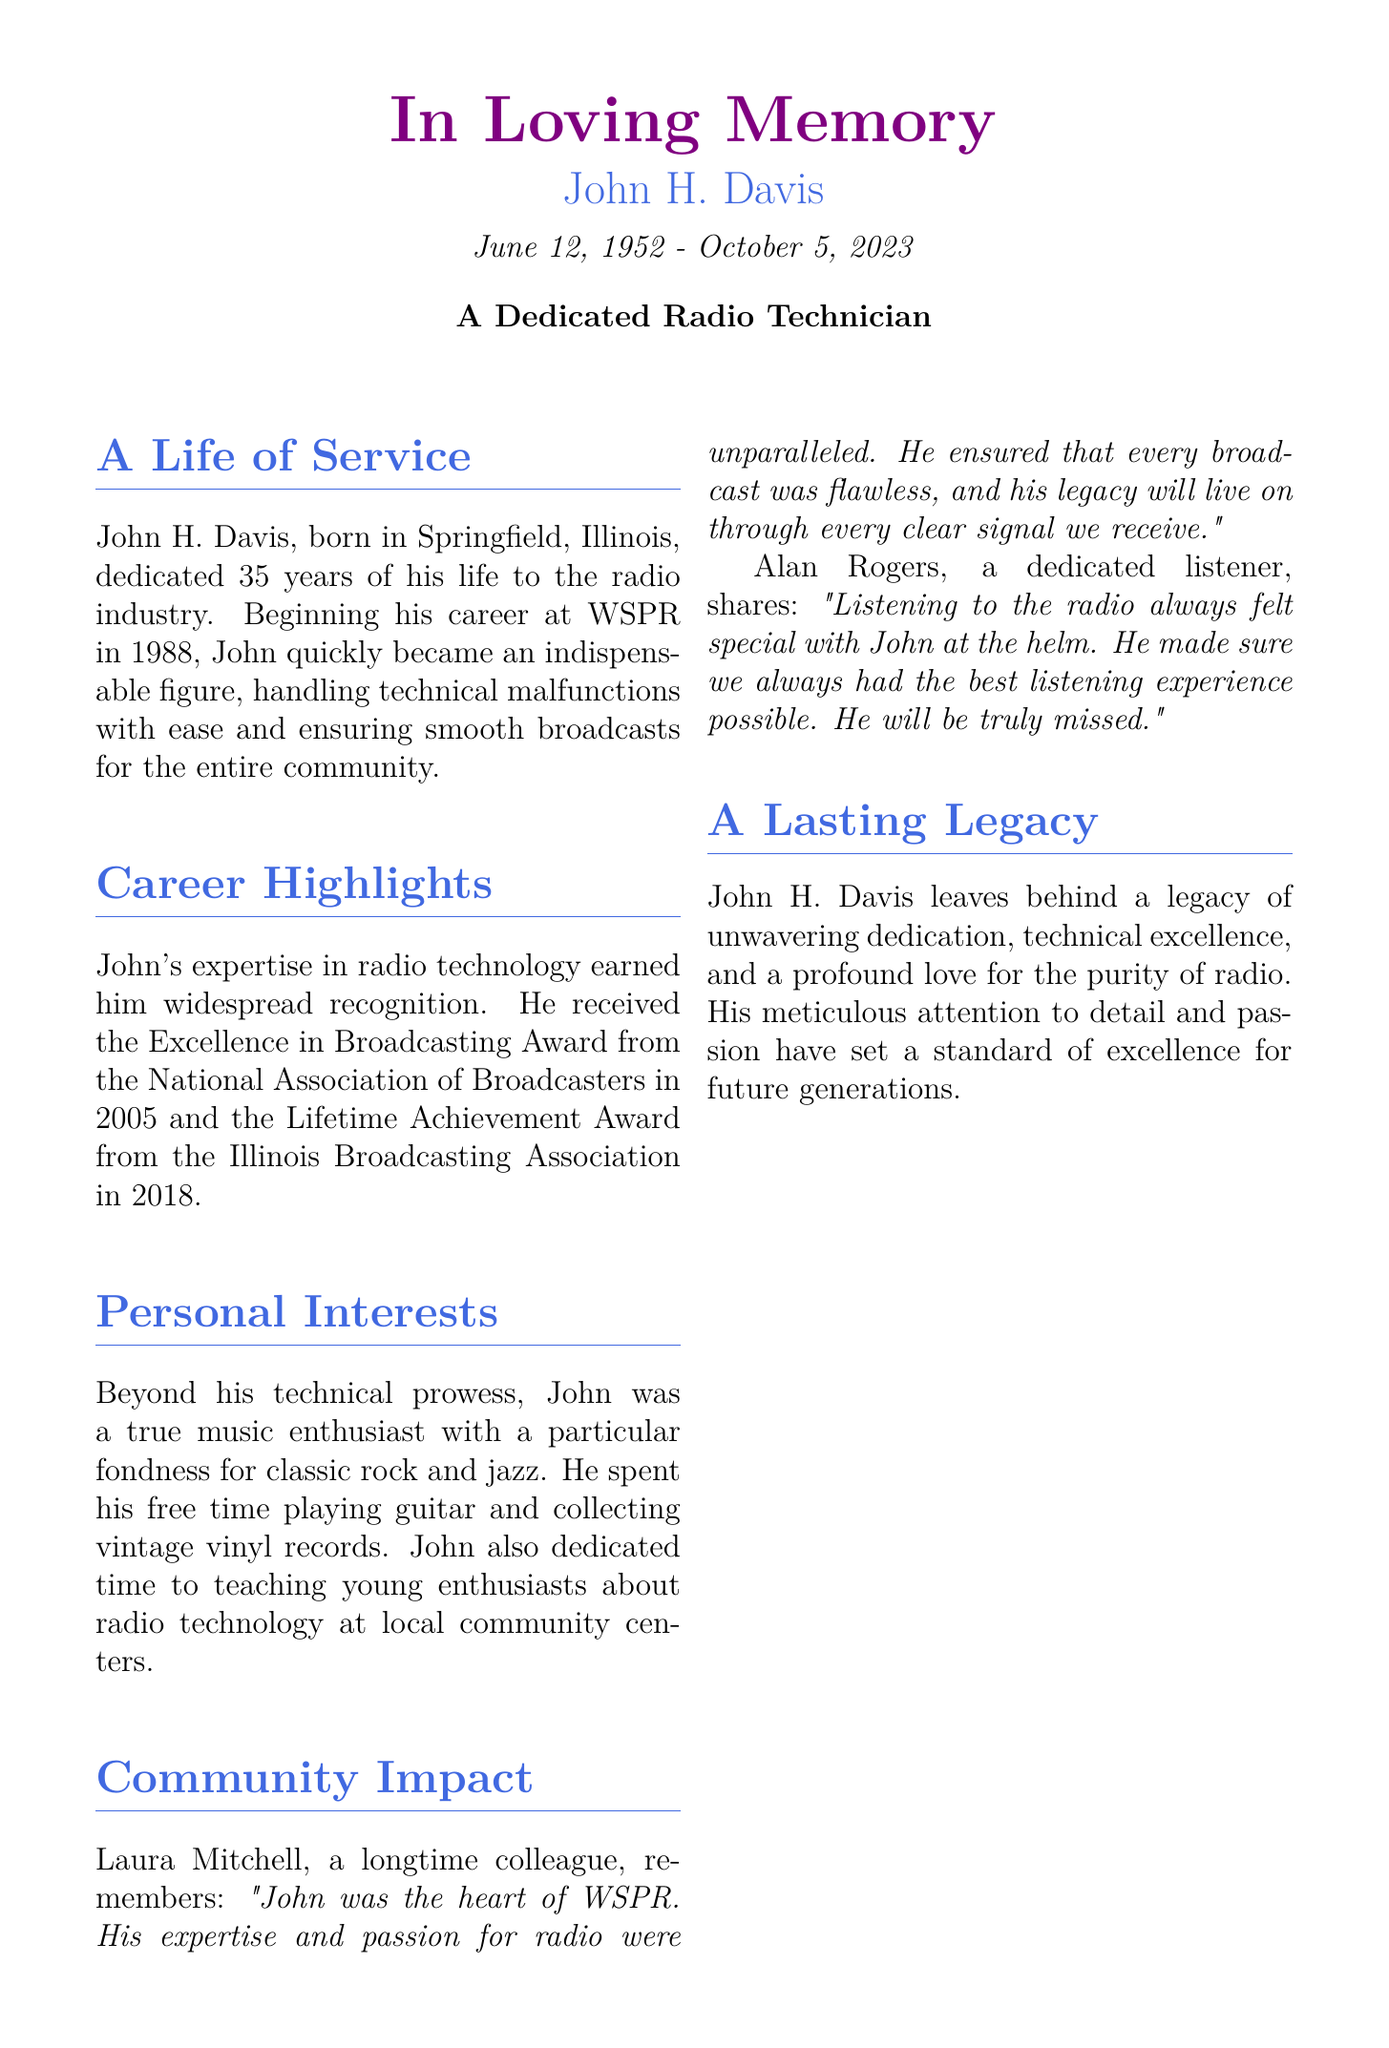What was John H. Davis's profession? The document states that John H. Davis was a radio technician dedicated to the radio industry.
Answer: radio technician When did John start his career at WSPR? The document mentions that John began his career at WSPR in 1988.
Answer: 1988 What award did John receive in 2005? The document notes that John received the Excellence in Broadcasting Award from the National Association of Broadcasters in 2005.
Answer: Excellence in Broadcasting Award Who is John survived by? The document lists John's family, indicating he is survived by his wife and children.
Answer: Margaret, Rebecca, Samuel What is one of John's personal interests mentioned in the document? The document mentions that John had a fondness for classic rock and jazz.
Answer: classic rock and jazz What did Laura Mitchell say about John? The document includes Laura's remembrance stating that John was the heart of WSPR and had unparalleled expertise.
Answer: heart of WSPR What kind of legacy did John leave behind? The document describes John's legacy as one of unwavering dedication and technical excellence.
Answer: unwavering dedication, technical excellence In what year did John receive the Lifetime Achievement Award? The document states that John received the Lifetime Achievement Award from the Illinois Broadcasting Association in 2018.
Answer: 2018 What quote is attributed to Alan Rogers? The document includes Alan's sentiment about listening to the radio, emphasizing John's role in it.
Answer: Listening to the radio always felt special with John at the helm 